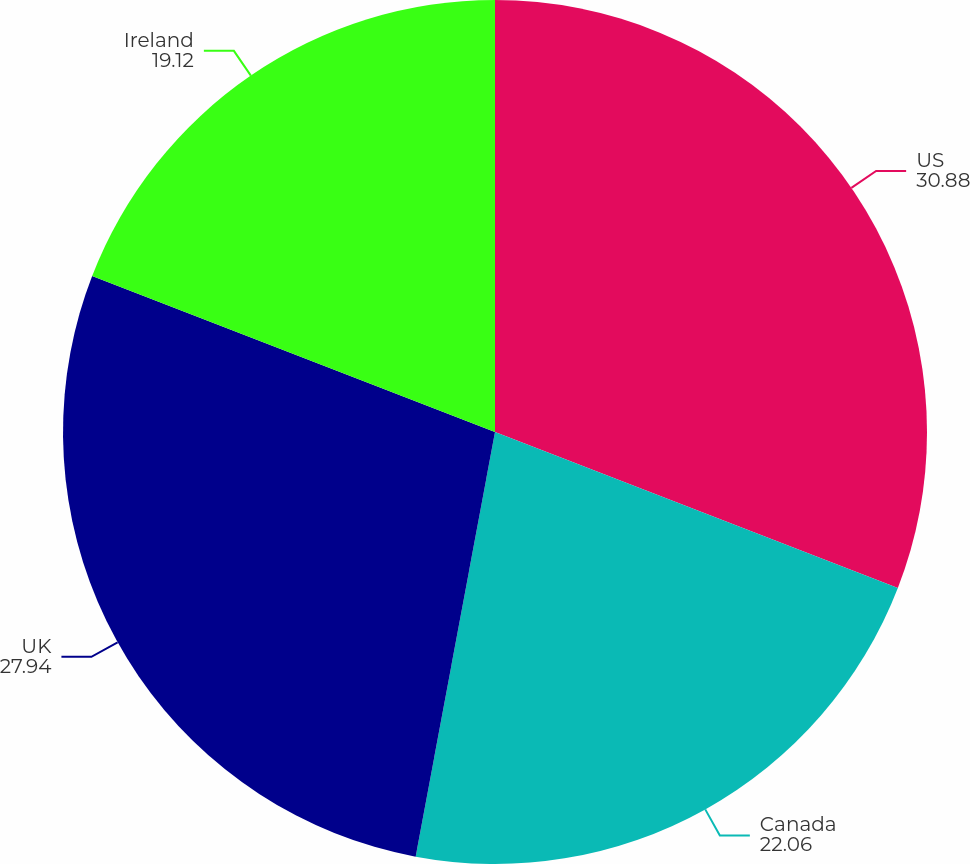<chart> <loc_0><loc_0><loc_500><loc_500><pie_chart><fcel>US<fcel>Canada<fcel>UK<fcel>Ireland<nl><fcel>30.88%<fcel>22.06%<fcel>27.94%<fcel>19.12%<nl></chart> 